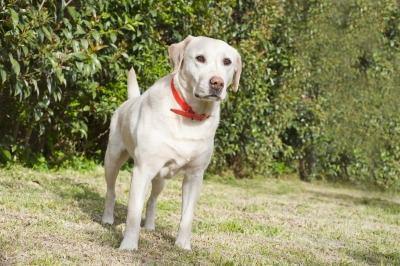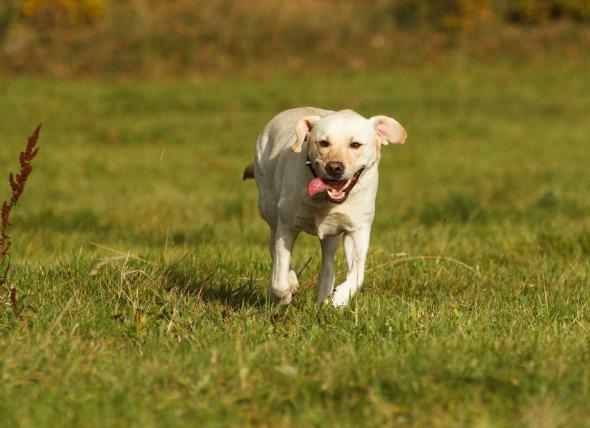The first image is the image on the left, the second image is the image on the right. For the images displayed, is the sentence "A large stick-like object is on the grass near a dog in one image." factually correct? Answer yes or no. No. 